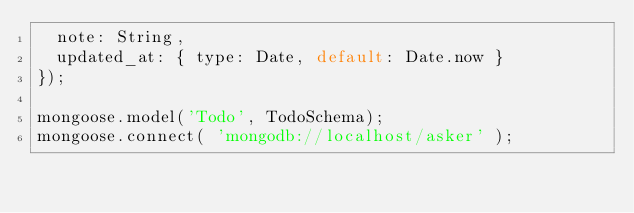<code> <loc_0><loc_0><loc_500><loc_500><_JavaScript_>	note: String,
	updated_at: { type: Date, default: Date.now }
});

mongoose.model('Todo', TodoSchema);
mongoose.connect( 'mongodb://localhost/asker' );</code> 